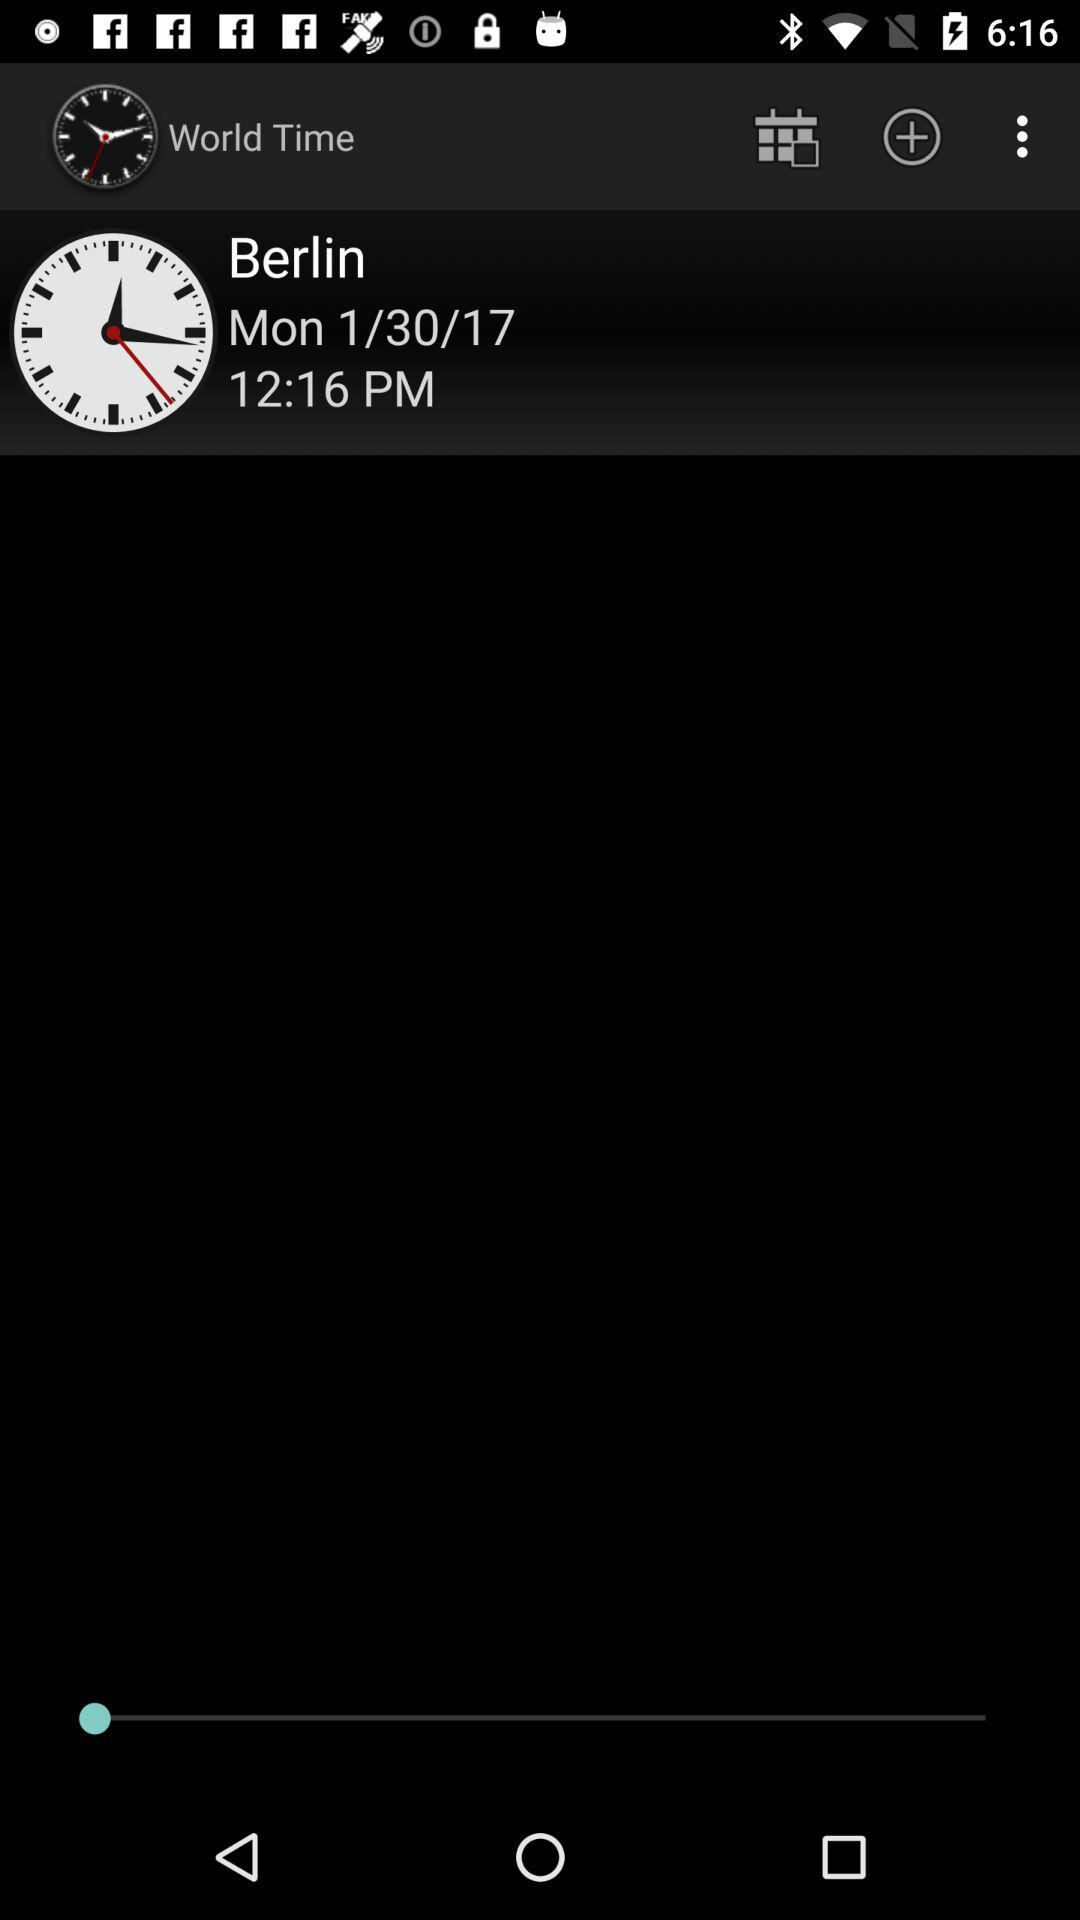What time is shown on the screen? The time shown on the screen is 12:16 p.m. 